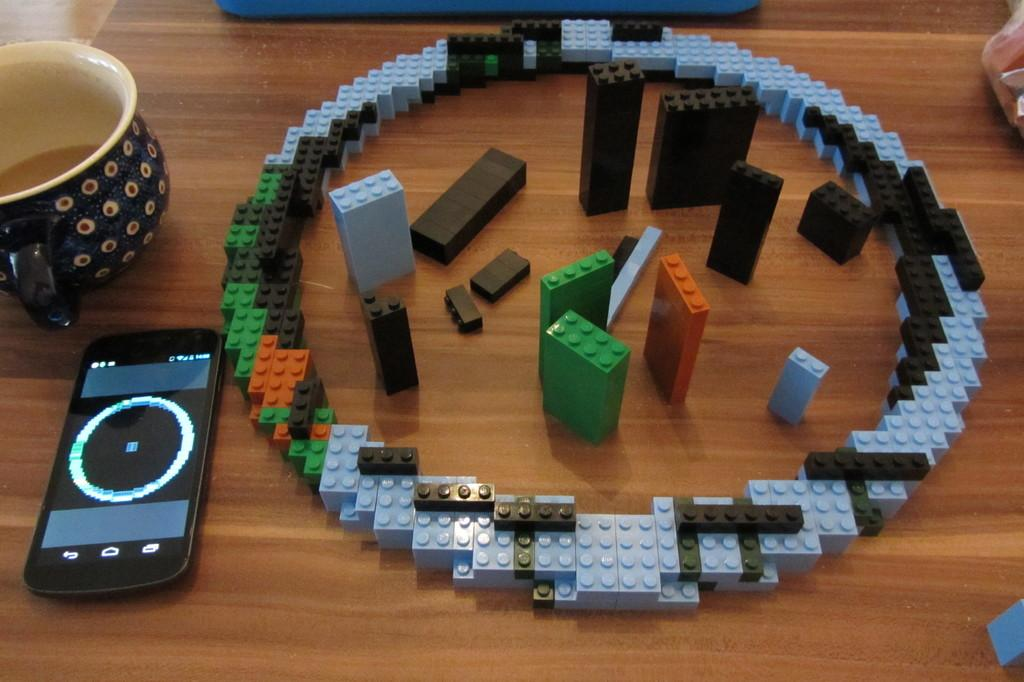What is the main setting of the image? The main setting of the image is a table. What can be found on the table in the image? There are objects placed on the table, including a cup and a smartphone. What time does the committee meet in the image? There is no mention of a committee or a specific time in the image. The image only shows objects placed on a table, including a cup and a smartphone. 